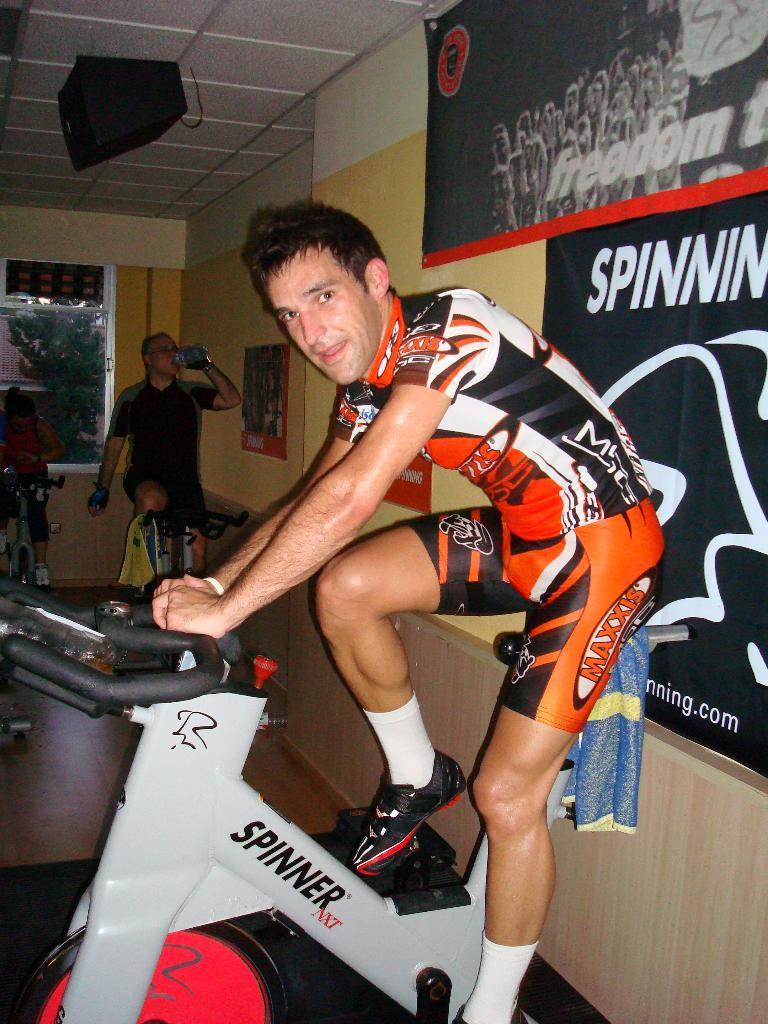Can you describe this image briefly? In this picture there are people sitting on gym equipment, among them there's a man holding a bottle and drinking. We can see floor and boards on the wall. In the background of the image we can see glass window, through glass window we can see leaves. At the top of the image we can see device attached to the roof. 